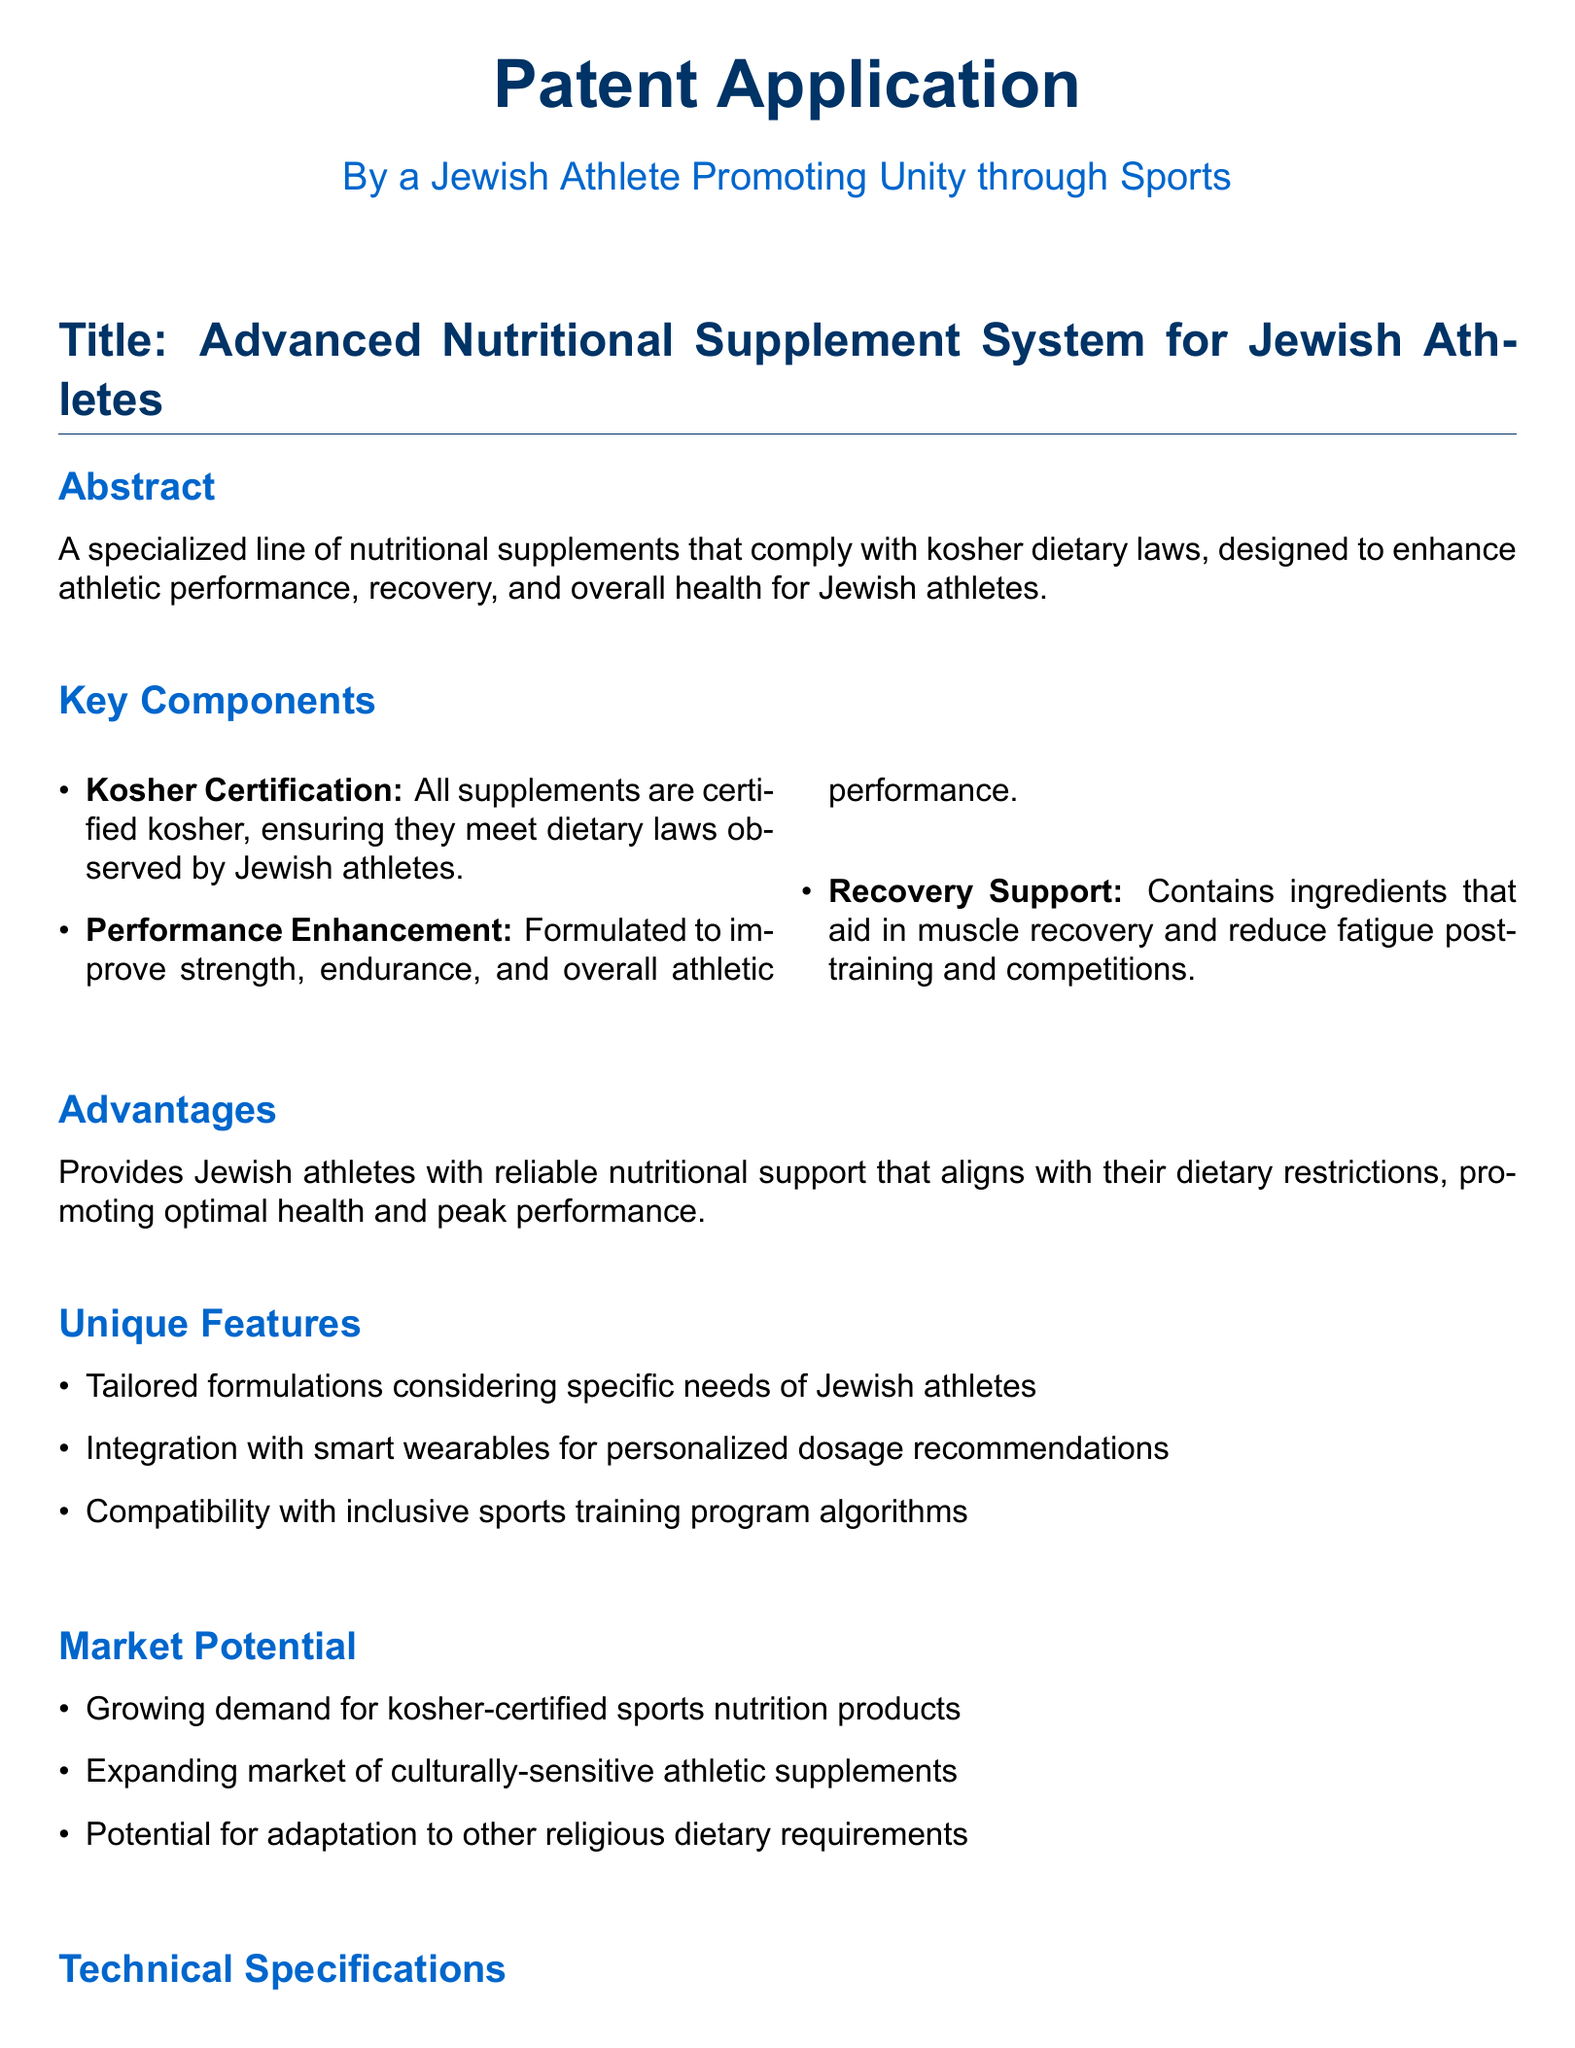what is the title of the patent application? The title is indicated at the beginning of the document.
Answer: Advanced Nutritional Supplement System for Jewish Athletes who is the author of the patent application? The author is mentioned in the document center.
Answer: A Jewish Athlete Promoting Unity through Sports what are the key components listed in the document? The key components are found in the relevant section detailing important features.
Answer: Kosher Certification, Performance Enhancement, Recovery Support what is one unique feature of the nutritional supplement system? Unique features are specified to highlight distinctive aspects of the product.
Answer: Tailored formulations considering specific needs of Jewish athletes what is the market potential mentioned in the patent? Market potential is discussed as it highlights the demand and opportunities for the product.
Answer: Growing demand for kosher-certified sports nutrition products which systems can the nutritional supplement system integrate with? The document specifies systems for integration to enhance functionality.
Answer: Smart Wearables for Monitoring Athletic Performance, Inclusive Sports Training Program Algorithms, Sports Event Management System for Cultural Unity how does this supplement system support Jewish athletes? The document explains the target audience and how it meets their specific needs.
Answer: Provides reliable nutritional support that aligns with their dietary restrictions what is the conclusion of the patent application? The conclusion summarizes the overarching message or significance of the application.
Answer: Represents a significant innovation in sports nutrition what is the purpose of the nutritional supplement system? The document describes the overarching aim of the invention.
Answer: To enhance athletic performance, recovery, and overall health for Jewish athletes 